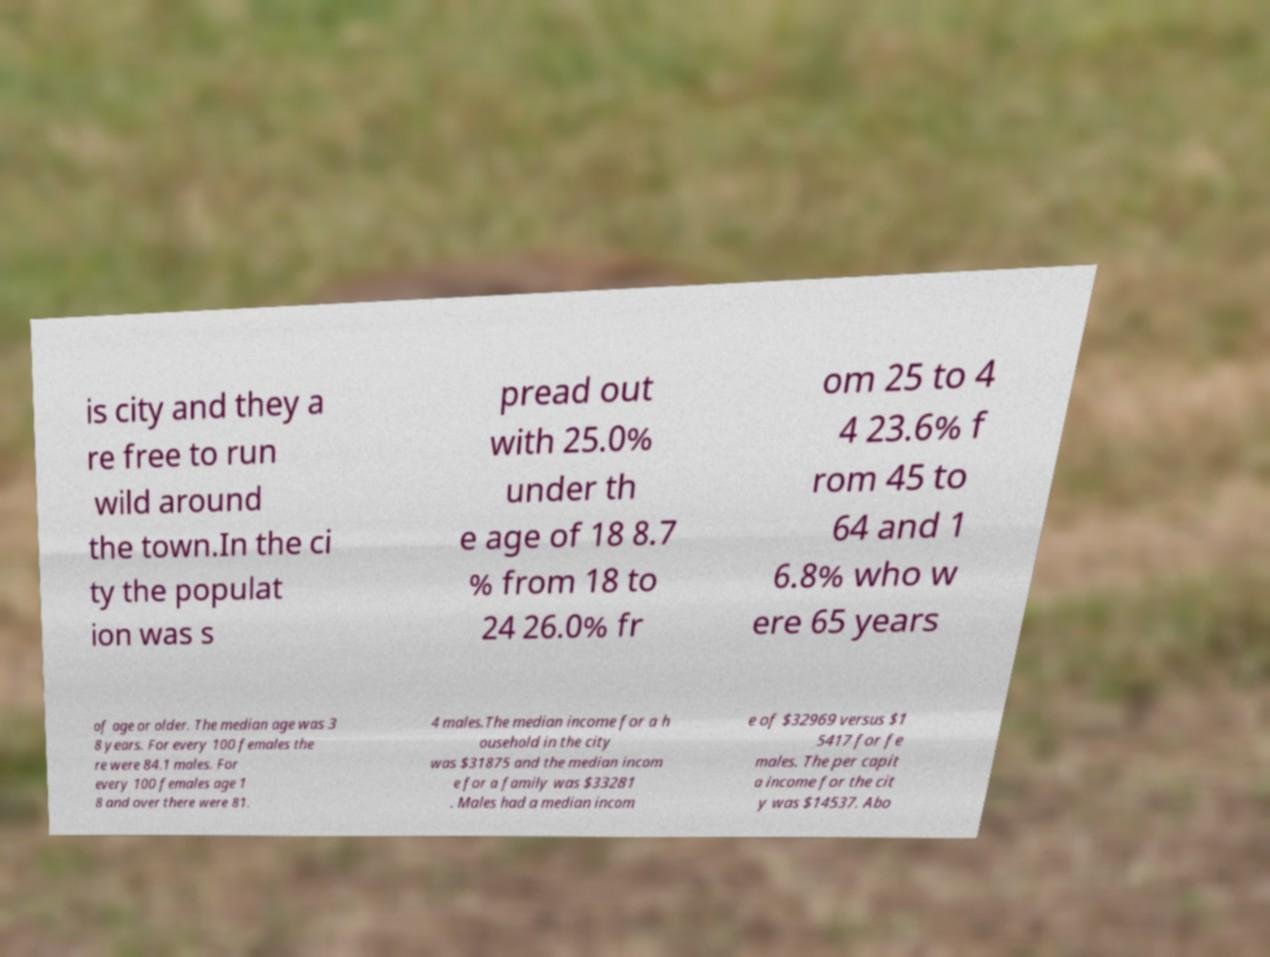Can you accurately transcribe the text from the provided image for me? is city and they a re free to run wild around the town.In the ci ty the populat ion was s pread out with 25.0% under th e age of 18 8.7 % from 18 to 24 26.0% fr om 25 to 4 4 23.6% f rom 45 to 64 and 1 6.8% who w ere 65 years of age or older. The median age was 3 8 years. For every 100 females the re were 84.1 males. For every 100 females age 1 8 and over there were 81. 4 males.The median income for a h ousehold in the city was $31875 and the median incom e for a family was $33281 . Males had a median incom e of $32969 versus $1 5417 for fe males. The per capit a income for the cit y was $14537. Abo 